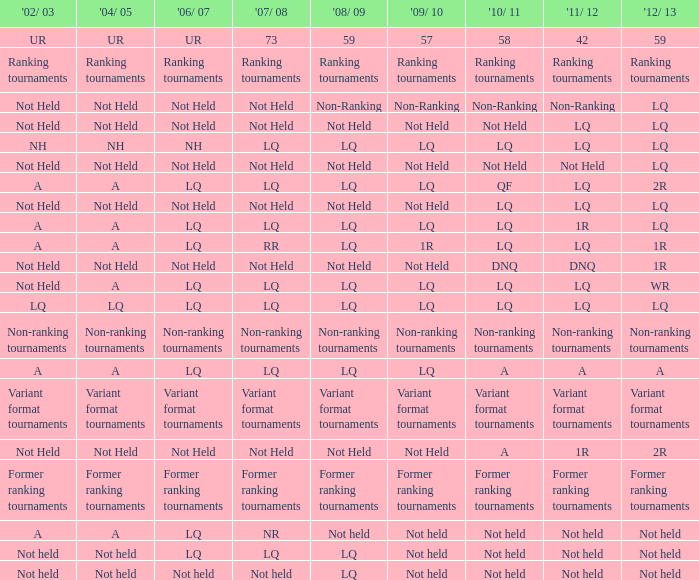Name the 2006/07 with 2011/12 of lq and 2010/11 of lq with 2002/03 of lq LQ. Could you parse the entire table? {'header': ["'02/ 03", "'04/ 05", "'06/ 07", "'07/ 08", "'08/ 09", "'09/ 10", "'10/ 11", "'11/ 12", "'12/ 13"], 'rows': [['UR', 'UR', 'UR', '73', '59', '57', '58', '42', '59'], ['Ranking tournaments', 'Ranking tournaments', 'Ranking tournaments', 'Ranking tournaments', 'Ranking tournaments', 'Ranking tournaments', 'Ranking tournaments', 'Ranking tournaments', 'Ranking tournaments'], ['Not Held', 'Not Held', 'Not Held', 'Not Held', 'Non-Ranking', 'Non-Ranking', 'Non-Ranking', 'Non-Ranking', 'LQ'], ['Not Held', 'Not Held', 'Not Held', 'Not Held', 'Not Held', 'Not Held', 'Not Held', 'LQ', 'LQ'], ['NH', 'NH', 'NH', 'LQ', 'LQ', 'LQ', 'LQ', 'LQ', 'LQ'], ['Not Held', 'Not Held', 'Not Held', 'Not Held', 'Not Held', 'Not Held', 'Not Held', 'Not Held', 'LQ'], ['A', 'A', 'LQ', 'LQ', 'LQ', 'LQ', 'QF', 'LQ', '2R'], ['Not Held', 'Not Held', 'Not Held', 'Not Held', 'Not Held', 'Not Held', 'LQ', 'LQ', 'LQ'], ['A', 'A', 'LQ', 'LQ', 'LQ', 'LQ', 'LQ', '1R', 'LQ'], ['A', 'A', 'LQ', 'RR', 'LQ', '1R', 'LQ', 'LQ', '1R'], ['Not Held', 'Not Held', 'Not Held', 'Not Held', 'Not Held', 'Not Held', 'DNQ', 'DNQ', '1R'], ['Not Held', 'A', 'LQ', 'LQ', 'LQ', 'LQ', 'LQ', 'LQ', 'WR'], ['LQ', 'LQ', 'LQ', 'LQ', 'LQ', 'LQ', 'LQ', 'LQ', 'LQ'], ['Non-ranking tournaments', 'Non-ranking tournaments', 'Non-ranking tournaments', 'Non-ranking tournaments', 'Non-ranking tournaments', 'Non-ranking tournaments', 'Non-ranking tournaments', 'Non-ranking tournaments', 'Non-ranking tournaments'], ['A', 'A', 'LQ', 'LQ', 'LQ', 'LQ', 'A', 'A', 'A'], ['Variant format tournaments', 'Variant format tournaments', 'Variant format tournaments', 'Variant format tournaments', 'Variant format tournaments', 'Variant format tournaments', 'Variant format tournaments', 'Variant format tournaments', 'Variant format tournaments'], ['Not Held', 'Not Held', 'Not Held', 'Not Held', 'Not Held', 'Not Held', 'A', '1R', '2R'], ['Former ranking tournaments', 'Former ranking tournaments', 'Former ranking tournaments', 'Former ranking tournaments', 'Former ranking tournaments', 'Former ranking tournaments', 'Former ranking tournaments', 'Former ranking tournaments', 'Former ranking tournaments'], ['A', 'A', 'LQ', 'NR', 'Not held', 'Not held', 'Not held', 'Not held', 'Not held'], ['Not held', 'Not held', 'LQ', 'LQ', 'LQ', 'Not held', 'Not held', 'Not held', 'Not held'], ['Not held', 'Not held', 'Not held', 'Not held', 'LQ', 'Not held', 'Not held', 'Not held', 'Not held']]} 